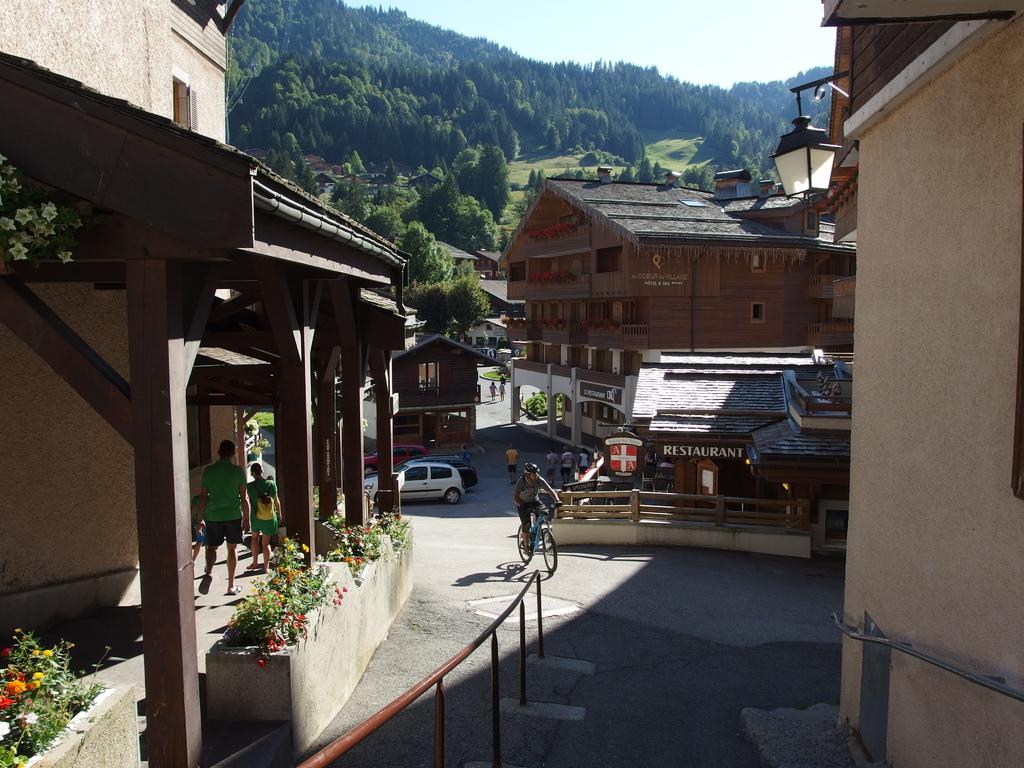What is the type of place shown in the street indicated by the words written on it?
Your response must be concise. Restaurant. 